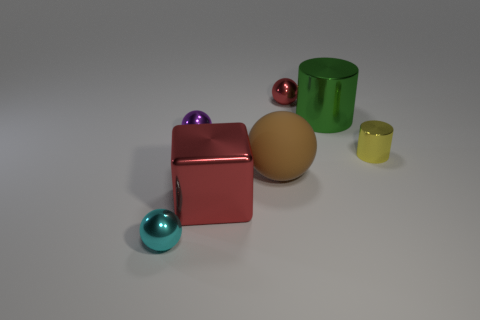Can you describe the color composition in the image? The image presents a range of colors. There's a small red cube, a large green cylinder, a large beige sphere, a small yellow cylinder, and two small spheres, one teal and one purple. 